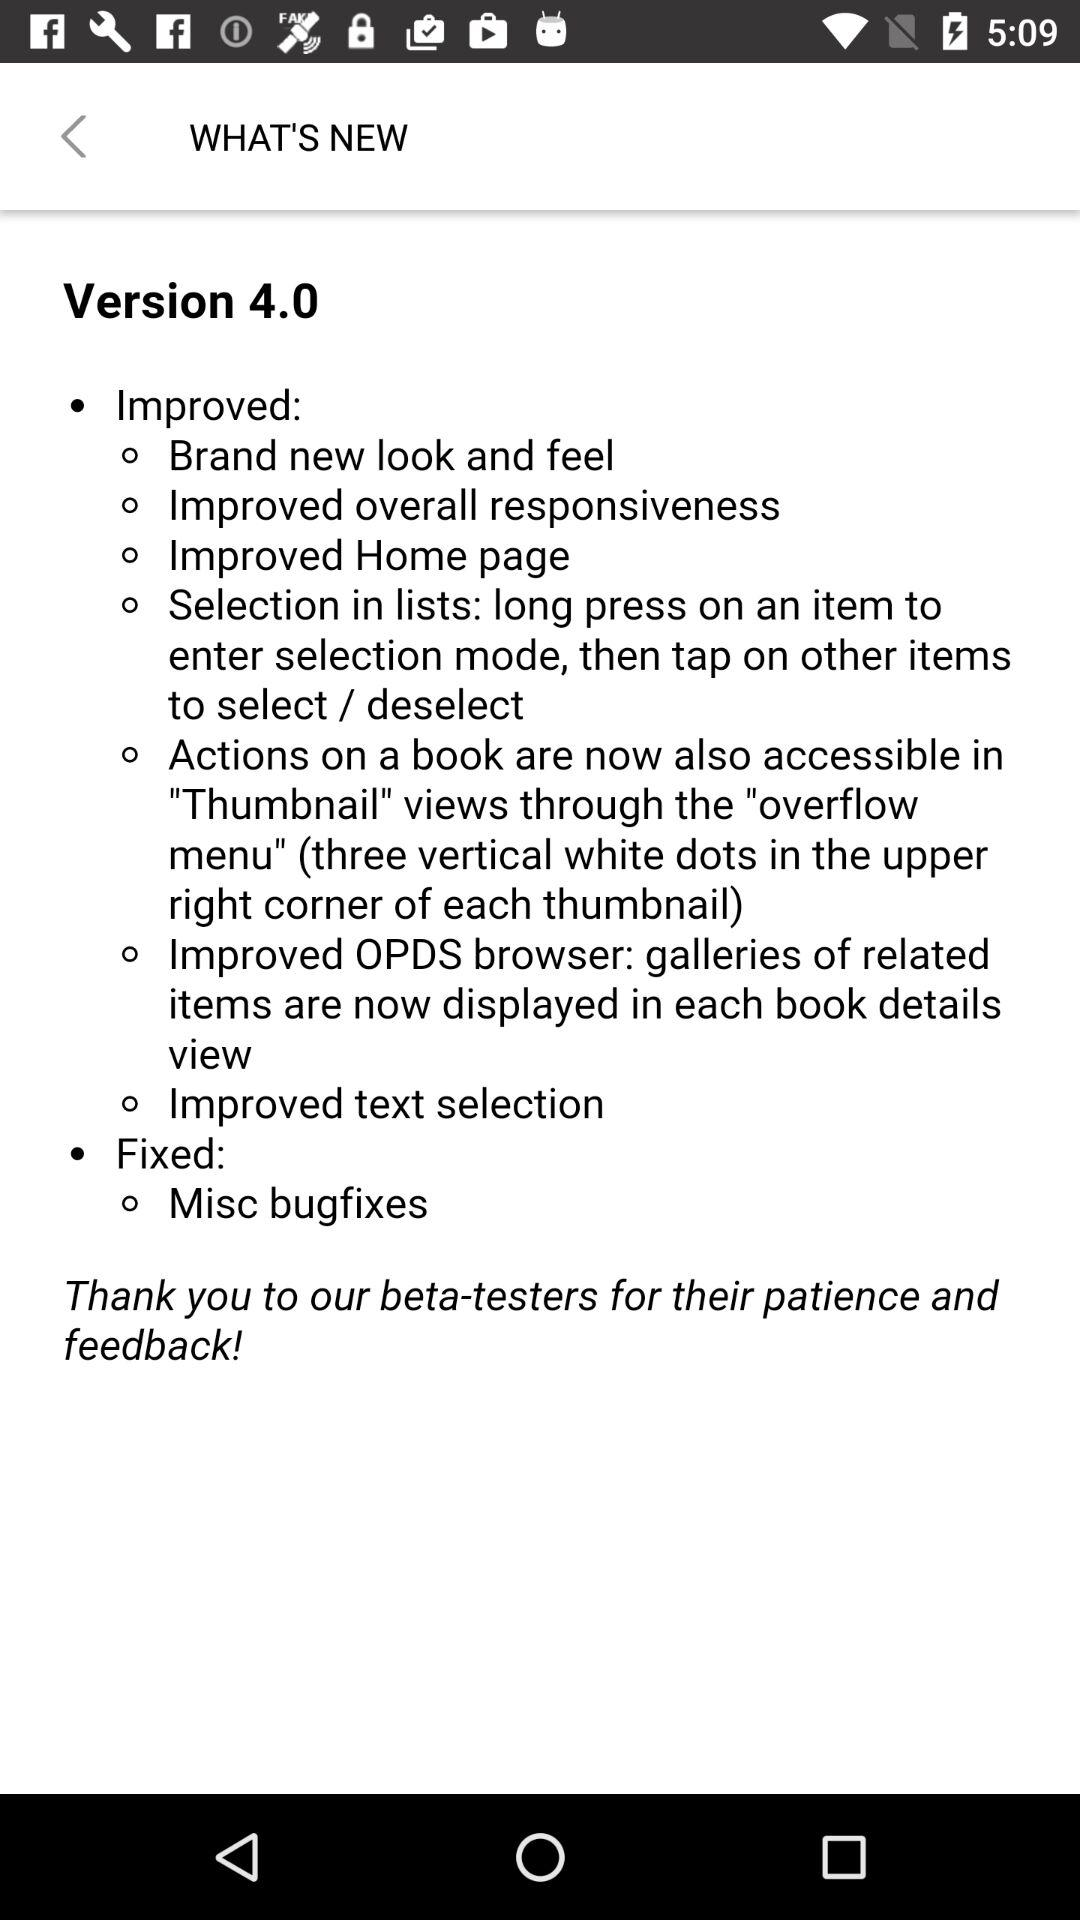How many different kinds of bugs are fixed in this release?
Answer the question using a single word or phrase. 1 